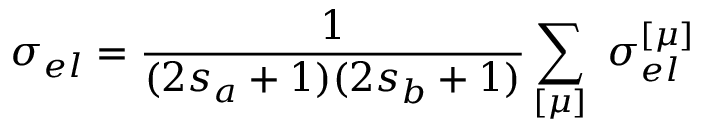Convert formula to latex. <formula><loc_0><loc_0><loc_500><loc_500>\sigma _ { e l } = \frac { 1 } { ( 2 s _ { a } + 1 ) ( 2 s _ { b } + 1 ) } \sum _ { [ \mu ] } \, \sigma _ { e l } ^ { [ \mu ] }</formula> 